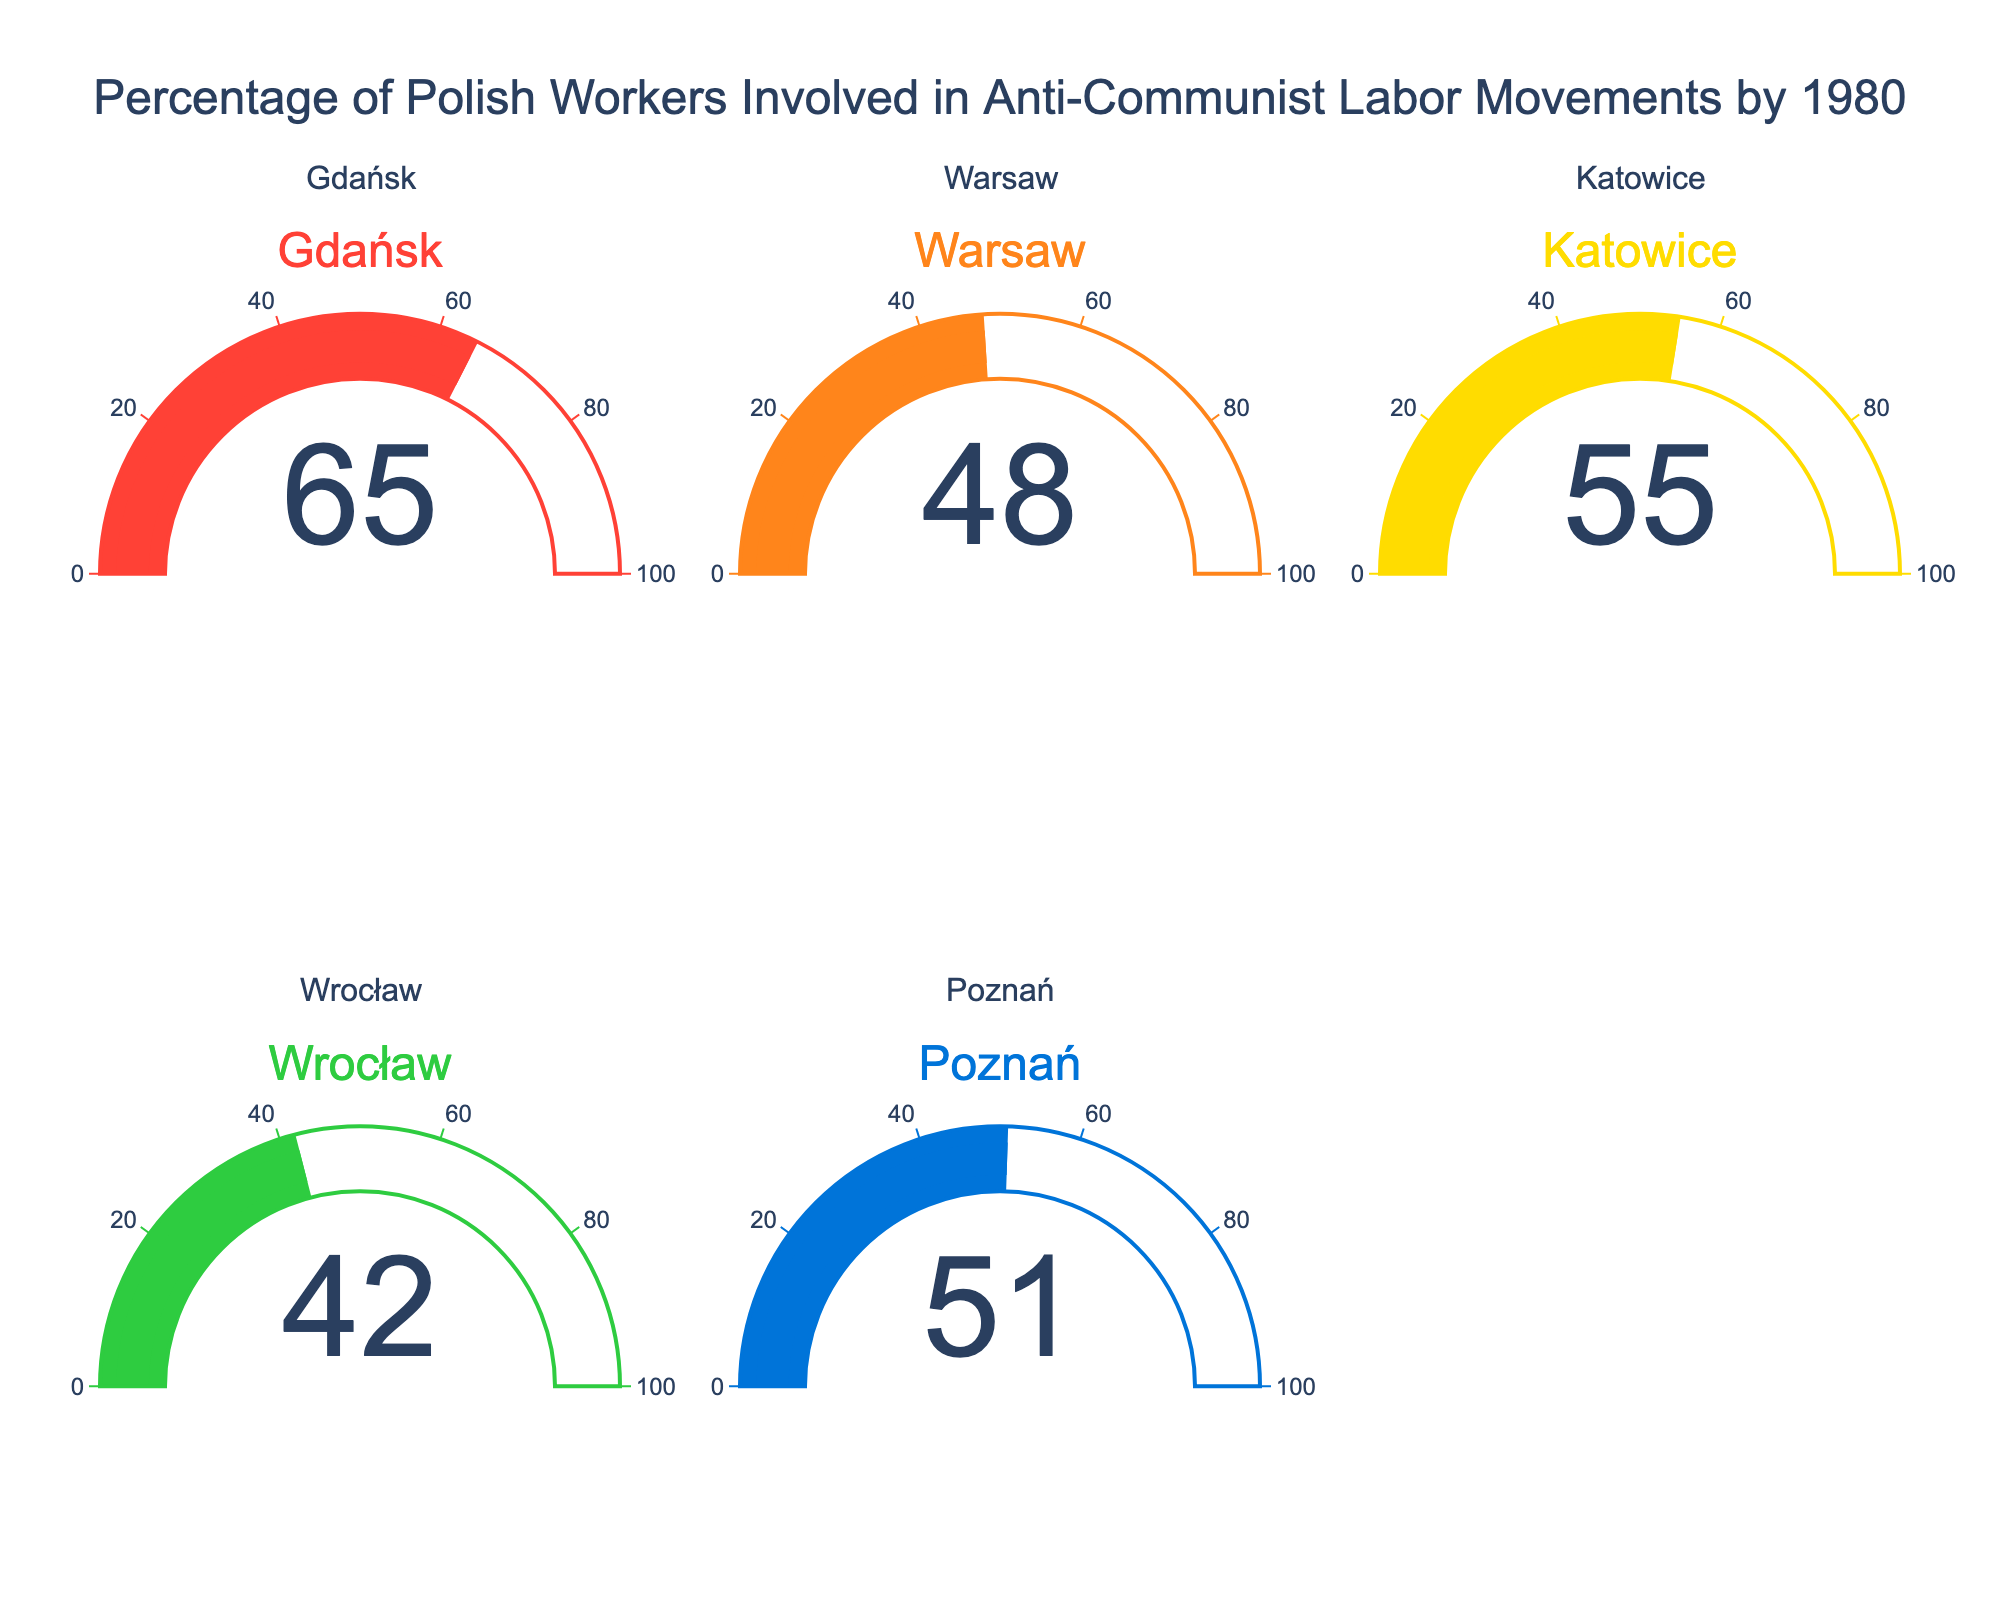what is the title of the figure? The title is located at the top center of the figure and summarizes the content. The phrase displayed here is "Percentage of Polish Workers Involved in Anti-Communist Labor Movements by 1980"
Answer: Percentage of Polish Workers Involved in Anti-Communist Labor Movements by 1980 Which region has the highest percentage of workers involved in anti-communist labor movements? By comparing all the gauges, the highest value is found in the gauge labeled "Gdańsk" which shows 65%.
Answer: Gdańsk What is the average percentage of workers involved in anti-communist labor movements across all regions? Sum up all percentage values: (65 + 48 + 55 + 42 + 51) = 261. There are 5 regions, so the average is 261 / 5 = 52.2
Answer: 52.2 Which region has the lowest percentage of workers involved in these movements? By comparing all the gauges, the lowest value is found in the gauge labeled "Wrocław" which shows 42%.
Answer: Wrocław What's the difference in the percentage of workers involved in anti-communist labor movements between Gdańsk and Warsaw? Subtract the percentage of Warsaw from Gdańsk: 65 - 48 = 17
Answer: 17 How many regions have a percentage of 50% or higher involved in anti-communist labor movements? Identify the regions with percentages ≥ 50: Gdańsk (65), Warsaw (48 no), Katowice (55), Wrocław (42 no), Poznań (51). The total count is 3
Answer: 3 What is the ratio of the highest percentage to the lowest percentage shown in the figure? Divide the highest percentage by the lowest percentage: 65 / 42 = approximately 1.55
Answer: 1.55 Which regions have a greater percentage of workers involved in anti-communist labor movements than Poznań? Identify the regions with percentages greater than 51: Gdańsk (65), Katowice (55), Warsaw (48 no), Wrocław (42 no). The regions are Gdańsk and Katowice
Answer: Gdańsk, Katowice What is the median percentage of workers involved in these movements across all regions? First, list the percentages in order: [42, 48, 51, 55, 65]. The middle value in this odd-numbered list is the third value which is 51
Answer: 51 Which region shows a value closest to the national average calculated from the figure? The national average is 52.2. Compare each region's value to this average to find the closest: Gdańsk (65-52.2 = 12.8), Warsaw (52.2-48 = 4.2), Katowice (55-52.2 = 2.8), Wrocław (52.2-42 = 10.2), Poznań (52.2-51 = 1.2). Therefore, Poznań is the closest
Answer: Poznań 